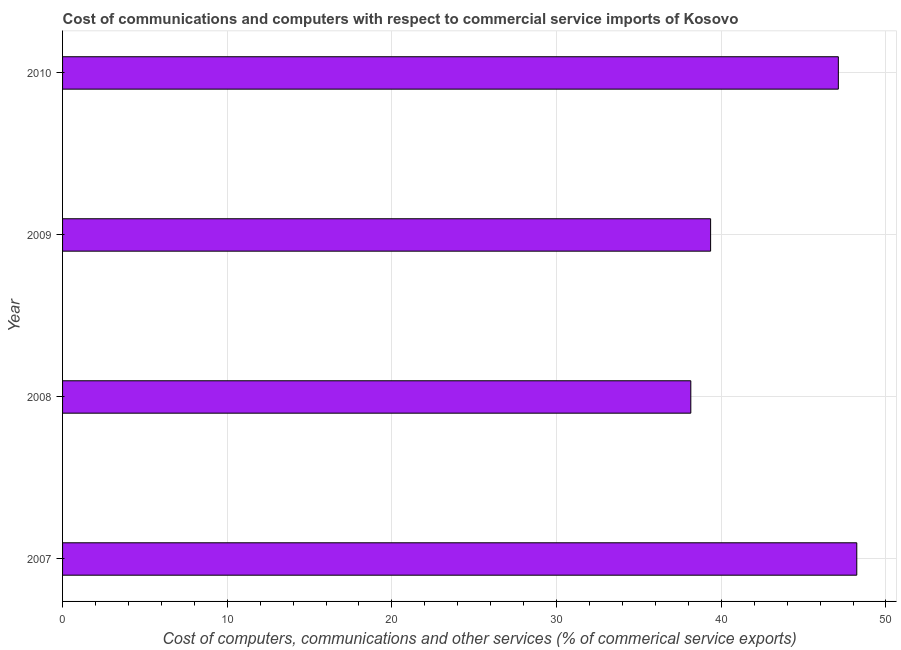What is the title of the graph?
Keep it short and to the point. Cost of communications and computers with respect to commercial service imports of Kosovo. What is the label or title of the X-axis?
Your answer should be very brief. Cost of computers, communications and other services (% of commerical service exports). What is the cost of communications in 2008?
Your answer should be very brief. 38.15. Across all years, what is the maximum  computer and other services?
Ensure brevity in your answer.  48.23. Across all years, what is the minimum  computer and other services?
Provide a short and direct response. 38.15. What is the sum of the cost of communications?
Offer a terse response. 172.84. What is the difference between the  computer and other services in 2009 and 2010?
Make the answer very short. -7.76. What is the average cost of communications per year?
Your response must be concise. 43.21. What is the median  computer and other services?
Your answer should be very brief. 43.23. What is the ratio of the cost of communications in 2008 to that in 2010?
Offer a terse response. 0.81. Is the  computer and other services in 2009 less than that in 2010?
Your answer should be compact. Yes. What is the difference between the highest and the second highest cost of communications?
Offer a very short reply. 1.12. What is the difference between the highest and the lowest cost of communications?
Provide a succinct answer. 10.08. How many years are there in the graph?
Provide a short and direct response. 4. Are the values on the major ticks of X-axis written in scientific E-notation?
Your answer should be compact. No. What is the Cost of computers, communications and other services (% of commerical service exports) in 2007?
Provide a short and direct response. 48.23. What is the Cost of computers, communications and other services (% of commerical service exports) in 2008?
Offer a terse response. 38.15. What is the Cost of computers, communications and other services (% of commerical service exports) of 2009?
Your answer should be compact. 39.35. What is the Cost of computers, communications and other services (% of commerical service exports) in 2010?
Ensure brevity in your answer.  47.11. What is the difference between the Cost of computers, communications and other services (% of commerical service exports) in 2007 and 2008?
Provide a short and direct response. 10.08. What is the difference between the Cost of computers, communications and other services (% of commerical service exports) in 2007 and 2009?
Provide a short and direct response. 8.88. What is the difference between the Cost of computers, communications and other services (% of commerical service exports) in 2007 and 2010?
Offer a terse response. 1.12. What is the difference between the Cost of computers, communications and other services (% of commerical service exports) in 2008 and 2009?
Your response must be concise. -1.2. What is the difference between the Cost of computers, communications and other services (% of commerical service exports) in 2008 and 2010?
Your answer should be compact. -8.96. What is the difference between the Cost of computers, communications and other services (% of commerical service exports) in 2009 and 2010?
Make the answer very short. -7.76. What is the ratio of the Cost of computers, communications and other services (% of commerical service exports) in 2007 to that in 2008?
Your response must be concise. 1.26. What is the ratio of the Cost of computers, communications and other services (% of commerical service exports) in 2007 to that in 2009?
Offer a very short reply. 1.23. What is the ratio of the Cost of computers, communications and other services (% of commerical service exports) in 2007 to that in 2010?
Ensure brevity in your answer.  1.02. What is the ratio of the Cost of computers, communications and other services (% of commerical service exports) in 2008 to that in 2010?
Ensure brevity in your answer.  0.81. What is the ratio of the Cost of computers, communications and other services (% of commerical service exports) in 2009 to that in 2010?
Make the answer very short. 0.83. 